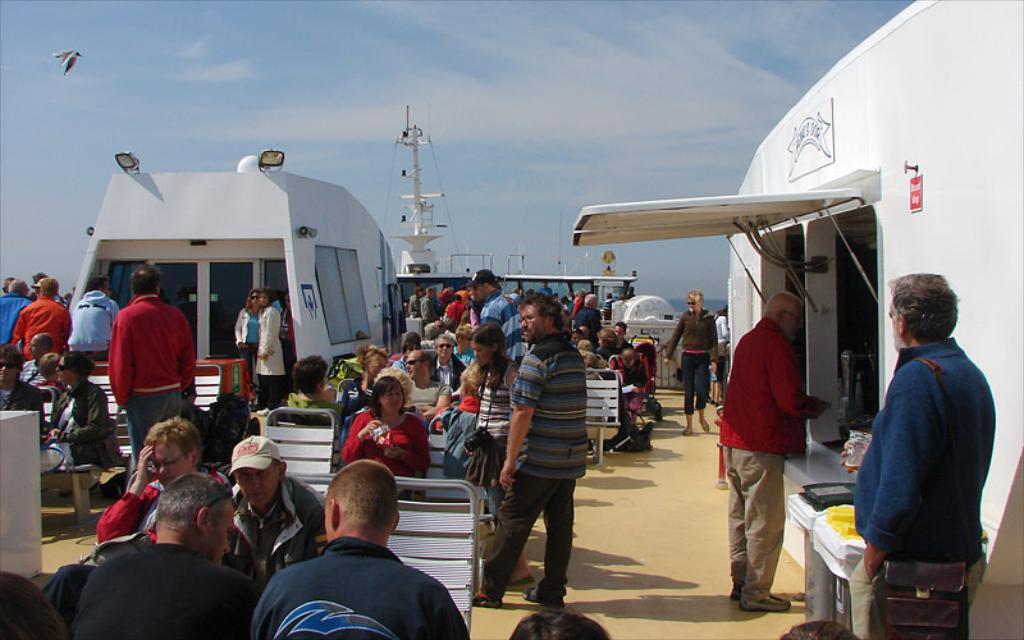Describe this image in one or two sentences. In this picture we can see some people sitting on chairs, there are some people standing here, on the right side there is a truck, we can see lights here, in the background there is the sky, this man is holding a glass, this man wore a cap. 